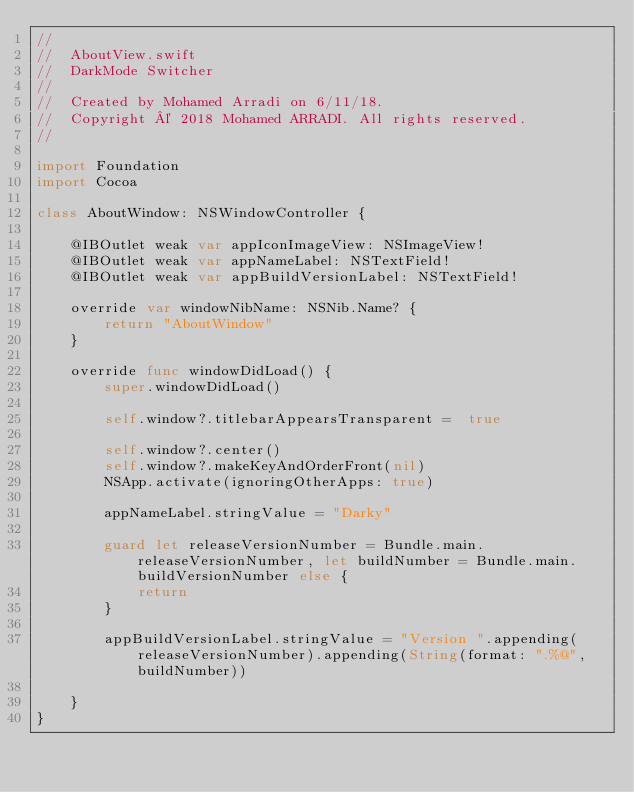<code> <loc_0><loc_0><loc_500><loc_500><_Swift_>//
//  AboutView.swift
//  DarkMode Switcher
//
//  Created by Mohamed Arradi on 6/11/18.
//  Copyright © 2018 Mohamed ARRADI. All rights reserved.
//

import Foundation
import Cocoa

class AboutWindow: NSWindowController {
    
    @IBOutlet weak var appIconImageView: NSImageView!
    @IBOutlet weak var appNameLabel: NSTextField!
    @IBOutlet weak var appBuildVersionLabel: NSTextField!
    
    override var windowNibName: NSNib.Name? {
        return "AboutWindow"
    }
    
    override func windowDidLoad() {
        super.windowDidLoad()
        
        self.window?.titlebarAppearsTransparent =  true
        
        self.window?.center()
        self.window?.makeKeyAndOrderFront(nil)
        NSApp.activate(ignoringOtherApps: true)
        
        appNameLabel.stringValue = "Darky"
       
        guard let releaseVersionNumber = Bundle.main.releaseVersionNumber, let buildNumber = Bundle.main.buildVersionNumber else {
            return
        }
        
        appBuildVersionLabel.stringValue = "Version ".appending(releaseVersionNumber).appending(String(format: ".%@", buildNumber))
        
    }
}
</code> 